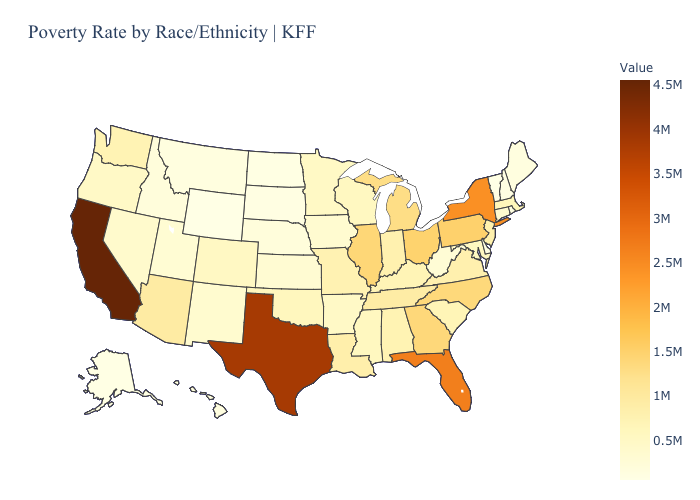Does Arizona have the lowest value in the USA?
Quick response, please. No. Does Massachusetts have the lowest value in the USA?
Quick response, please. No. Among the states that border Arkansas , which have the highest value?
Be succinct. Texas. Which states have the lowest value in the MidWest?
Give a very brief answer. North Dakota. Does Maine have the lowest value in the Northeast?
Answer briefly. No. Among the states that border South Carolina , does Georgia have the lowest value?
Short answer required. No. Does the map have missing data?
Be succinct. No. Does Massachusetts have the lowest value in the Northeast?
Be succinct. No. 